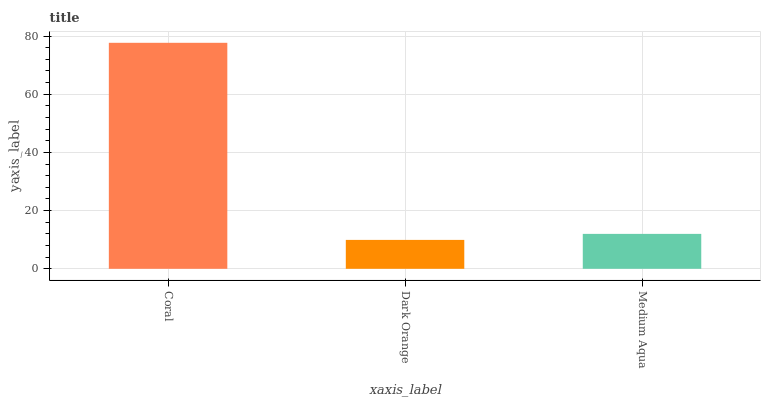Is Dark Orange the minimum?
Answer yes or no. Yes. Is Coral the maximum?
Answer yes or no. Yes. Is Medium Aqua the minimum?
Answer yes or no. No. Is Medium Aqua the maximum?
Answer yes or no. No. Is Medium Aqua greater than Dark Orange?
Answer yes or no. Yes. Is Dark Orange less than Medium Aqua?
Answer yes or no. Yes. Is Dark Orange greater than Medium Aqua?
Answer yes or no. No. Is Medium Aqua less than Dark Orange?
Answer yes or no. No. Is Medium Aqua the high median?
Answer yes or no. Yes. Is Medium Aqua the low median?
Answer yes or no. Yes. Is Coral the high median?
Answer yes or no. No. Is Coral the low median?
Answer yes or no. No. 